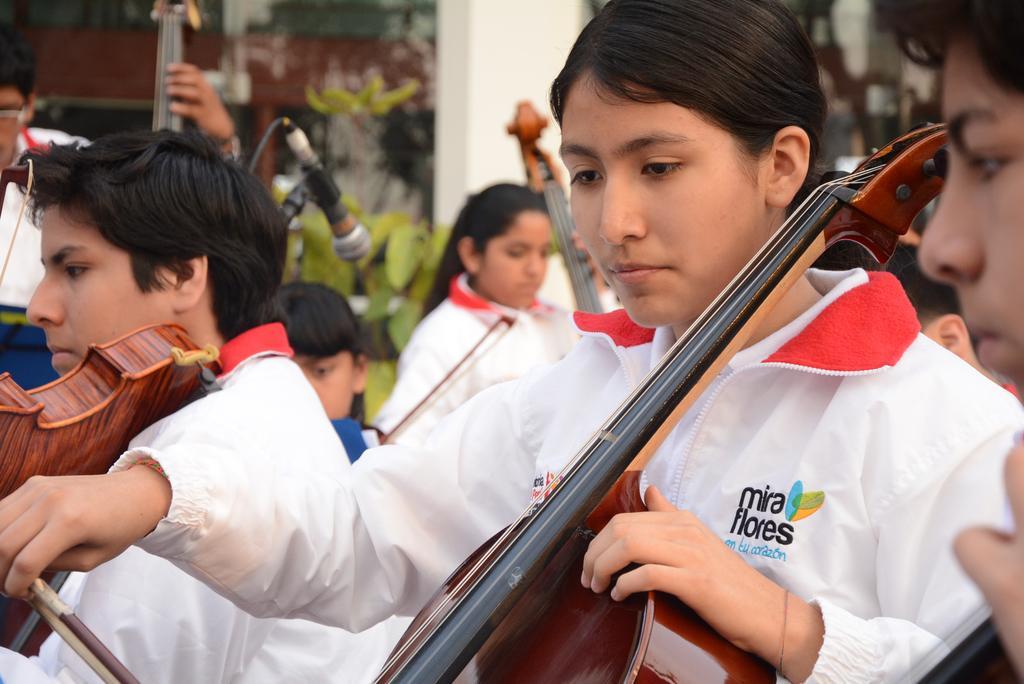In one or two sentences, can you explain what this image depicts? In the picture there are persons in which there are playing violin by catching with there hands there is a microphone we can say some trees near to them. 